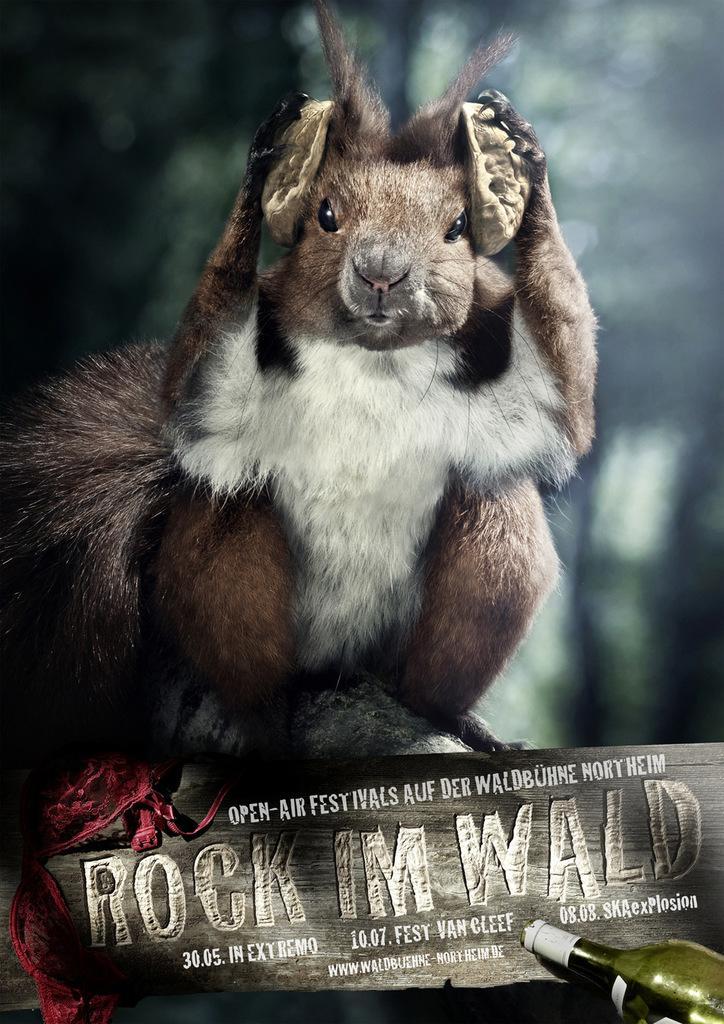Can you describe this image briefly? In this image there is one squirrel in the middle of the image, and in the bottom of the right corner there is one bottle and there is one wooden stick and some text is written on that wooden board. In the background of the image there are some trees. 